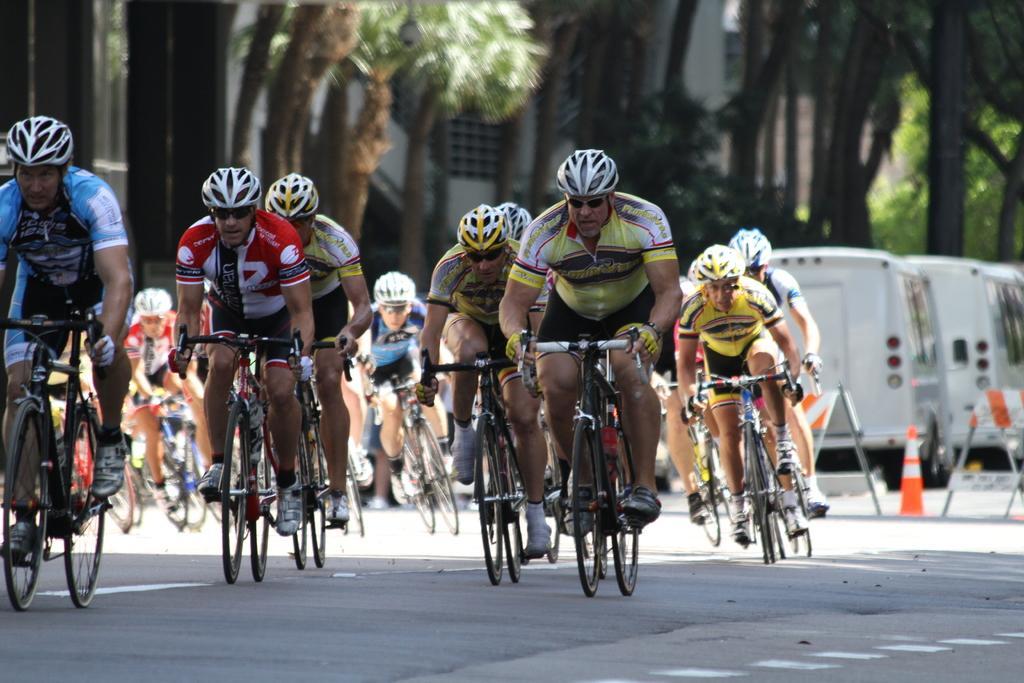In one or two sentences, can you explain what this image depicts? In this image there are a few people riding their bicycles on the road, there are few rods and traffic cones, behind that there are a few vehicles parked. In the background there are trees and buildings. 